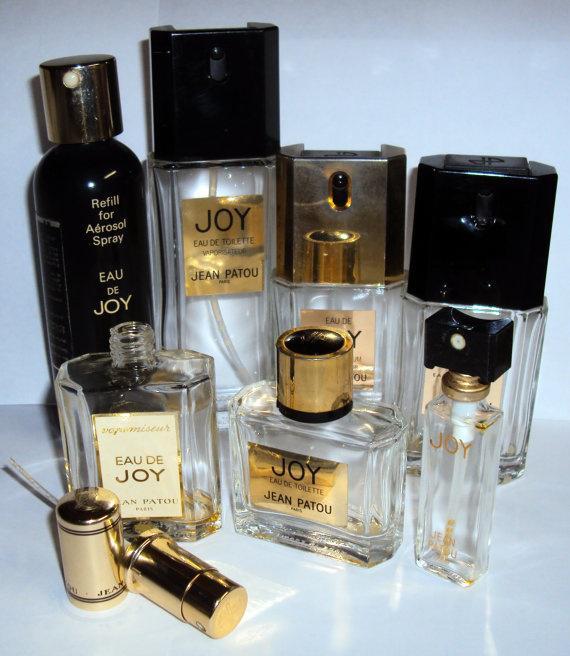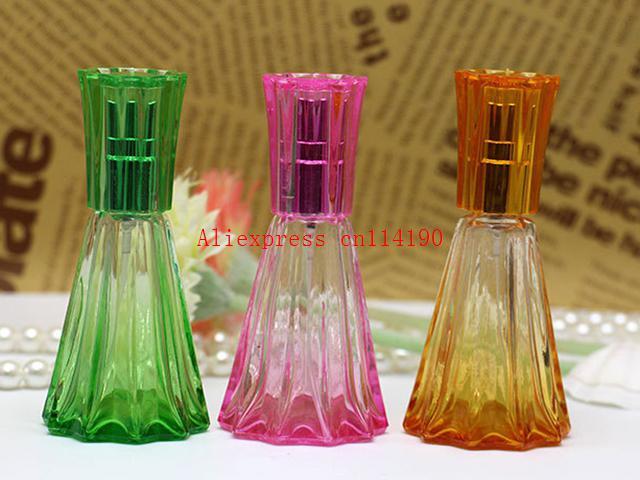The first image is the image on the left, the second image is the image on the right. Evaluate the accuracy of this statement regarding the images: "A website address is visible in both images.". Is it true? Answer yes or no. No. The first image is the image on the left, the second image is the image on the right. Examine the images to the left and right. Is the description "One of the images contains a bottle of perfume that is shaped like a woman's figure." accurate? Answer yes or no. No. 